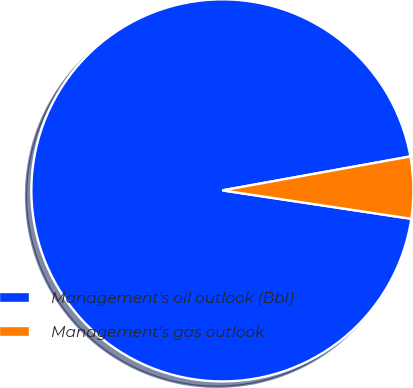<chart> <loc_0><loc_0><loc_500><loc_500><pie_chart><fcel>Management's oil outlook (Bbl)<fcel>Management's gas outlook<nl><fcel>94.78%<fcel>5.22%<nl></chart> 